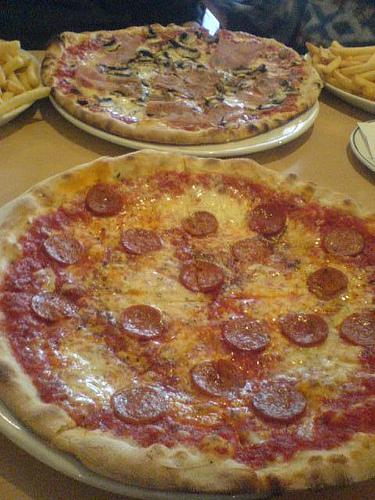Question: how many pizzas are in the picture?
Choices:
A. 3.
B. 4.
C. 2.
D. 5.
Answer with the letter. Answer: C Question: what color is the table?
Choices:
A. Brown.
B. White.
C. Tan.
D. Black.
Answer with the letter. Answer: C Question: where was this photo taken?
Choices:
A. Hot dog stand.
B. Resturant.
C. Pizza parlor.
D. Burrito shop.
Answer with the letter. Answer: B Question: what color is the cheese?
Choices:
A. Yellow.
B. Orange.
C. Red.
D. Brown.
Answer with the letter. Answer: A Question: how many plates of fries are in the picture?
Choices:
A. Three.
B. Two.
C. Four.
D. Five.
Answer with the letter. Answer: B Question: what color is the sauce on the first pizza?
Choices:
A. Brown.
B. Yellow.
C. Red.
D. Green.
Answer with the letter. Answer: C 